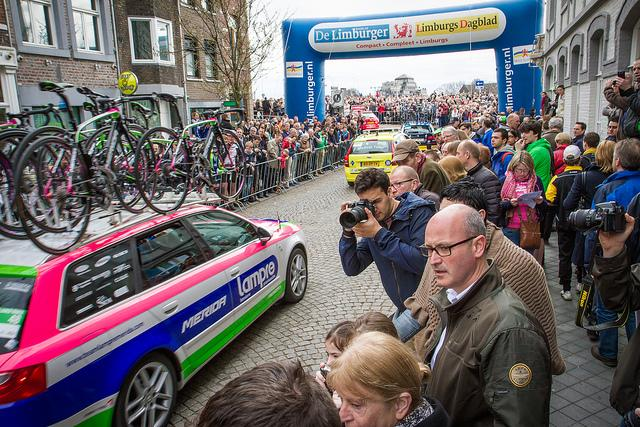What will the man in the blue sweatshirt do next?

Choices:
A) take photograph
B) give object
C) throw object
D) eat object take photograph 